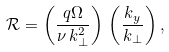<formula> <loc_0><loc_0><loc_500><loc_500>\mathcal { R } = \left ( \frac { q \Omega } { \nu \, k _ { \perp } ^ { 2 } } \right ) \, \left ( \frac { k _ { y } } { k _ { \perp } } \right ) ,</formula> 